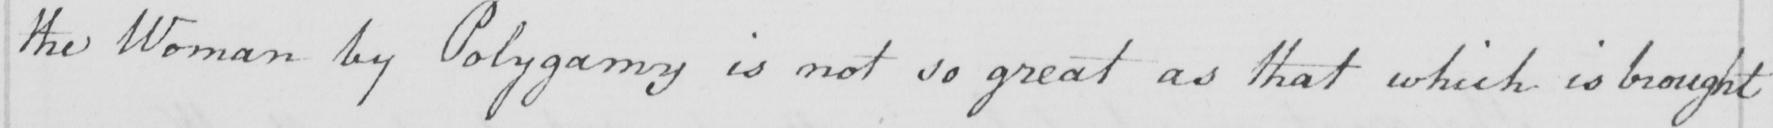Please provide the text content of this handwritten line. the Woman by Polygamy is not so great as that which is brought 